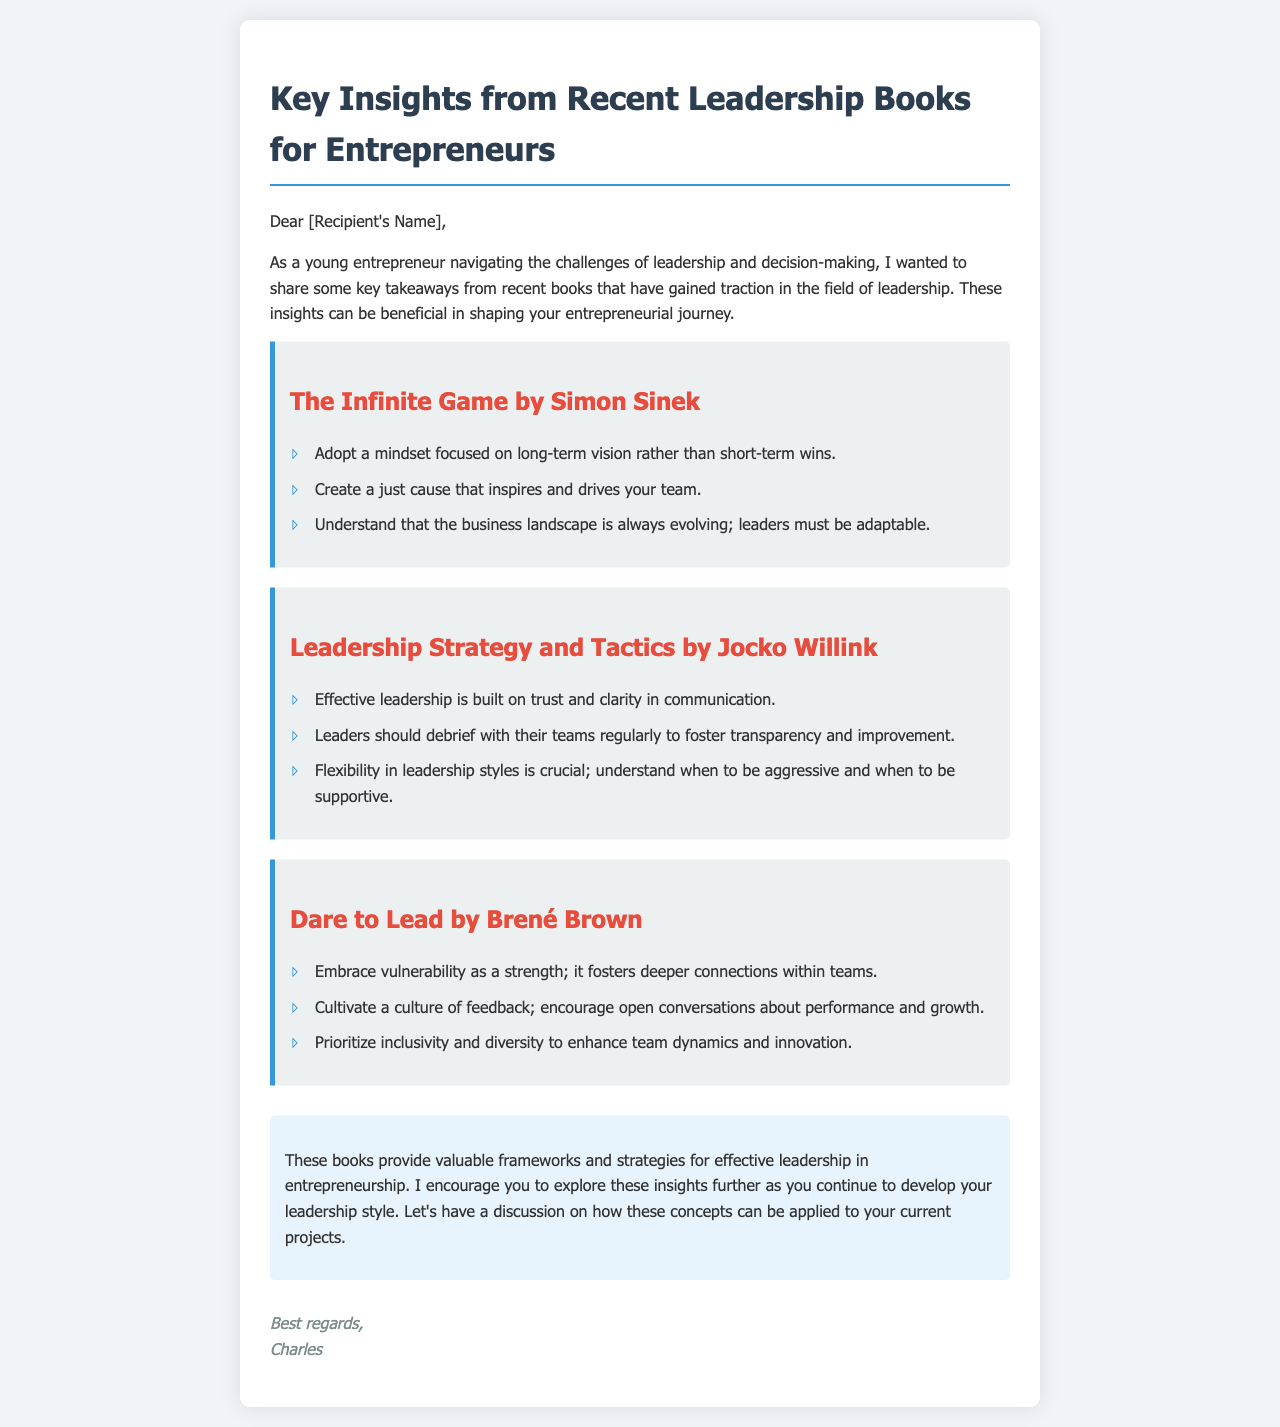what is the title of the first book mentioned? The first book mentioned in the document is titled “The Infinite Game” by Simon Sinek.
Answer: The Infinite Game who is the author of "Dare to Lead"? "Dare to Lead" is authored by Brené Brown.
Answer: Brené Brown how many key takeaways are listed for "Leadership Strategy and Tactics"? There are three key takeaways listed for "Leadership Strategy and Tactics".
Answer: 3 what mindset does "The Infinite Game" suggest adopting? "The Infinite Game" suggests adopting a mindset focused on long-term vision rather than short-term wins.
Answer: long-term vision what aspect of leadership does "Dare to Lead" emphasize as a strength? "Dare to Lead" emphasizes vulnerability as a strength.
Answer: vulnerability what is one recommended practice from "Leadership Strategy and Tactics"? One recommended practice is to debrief with teams regularly to foster transparency and improvement.
Answer: debrief with teams which book encourages cultivating a culture of feedback? "Dare to Lead" encourages cultivating a culture of feedback.
Answer: Dare to Lead what is the final suggestion provided in the conclusion? The final suggestion is to explore these insights further and discuss their application to current projects.
Answer: explore these insights further 